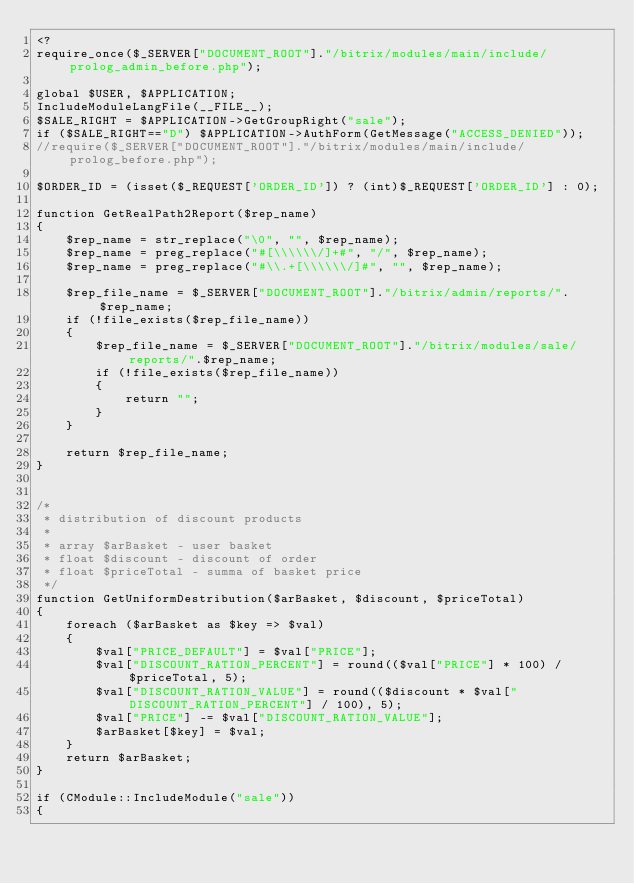<code> <loc_0><loc_0><loc_500><loc_500><_PHP_><?
require_once($_SERVER["DOCUMENT_ROOT"]."/bitrix/modules/main/include/prolog_admin_before.php");

global $USER, $APPLICATION;
IncludeModuleLangFile(__FILE__);
$SALE_RIGHT = $APPLICATION->GetGroupRight("sale");
if ($SALE_RIGHT=="D") $APPLICATION->AuthForm(GetMessage("ACCESS_DENIED"));
//require($_SERVER["DOCUMENT_ROOT"]."/bitrix/modules/main/include/prolog_before.php");

$ORDER_ID = (isset($_REQUEST['ORDER_ID']) ? (int)$_REQUEST['ORDER_ID'] : 0);

function GetRealPath2Report($rep_name)
{
	$rep_name = str_replace("\0", "", $rep_name);
	$rep_name = preg_replace("#[\\\\\\/]+#", "/", $rep_name);
	$rep_name = preg_replace("#\\.+[\\\\\\/]#", "", $rep_name);

	$rep_file_name = $_SERVER["DOCUMENT_ROOT"]."/bitrix/admin/reports/".$rep_name;
	if (!file_exists($rep_file_name))
	{
		$rep_file_name = $_SERVER["DOCUMENT_ROOT"]."/bitrix/modules/sale/reports/".$rep_name;
		if (!file_exists($rep_file_name))
		{
			return "";
		}
	}

	return $rep_file_name;
}


/*
 * distribution of discount products
 *
 * array $arBasket - user basket
 * float $discount - discount of order
 * float $priceTotal - summa of basket price
 */
function GetUniformDestribution($arBasket, $discount, $priceTotal)
{
	foreach ($arBasket as $key => $val)
	{
		$val["PRICE_DEFAULT"] = $val["PRICE"];
		$val["DISCOUNT_RATION_PERCENT"] = round(($val["PRICE"] * 100) / $priceTotal, 5);
		$val["DISCOUNT_RATION_VALUE"] = round(($discount * $val["DISCOUNT_RATION_PERCENT"] / 100), 5);
		$val["PRICE"] -= $val["DISCOUNT_RATION_VALUE"];
		$arBasket[$key] = $val;
	}
	return $arBasket;
}

if (CModule::IncludeModule("sale"))
{</code> 